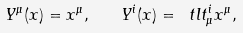<formula> <loc_0><loc_0><loc_500><loc_500>Y ^ { \mu } ( x ) = x ^ { \mu } , \quad Y ^ { i } ( x ) = \ t l t _ { \mu } ^ { i } x ^ { \mu } ,</formula> 